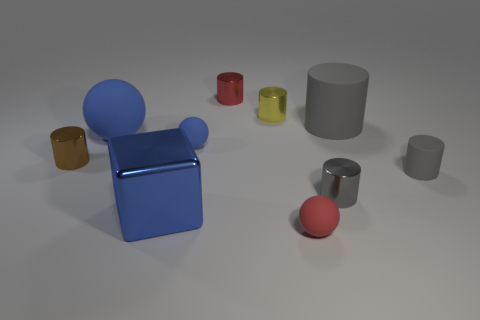What is the color of the other big thing that is the same shape as the brown object? gray 